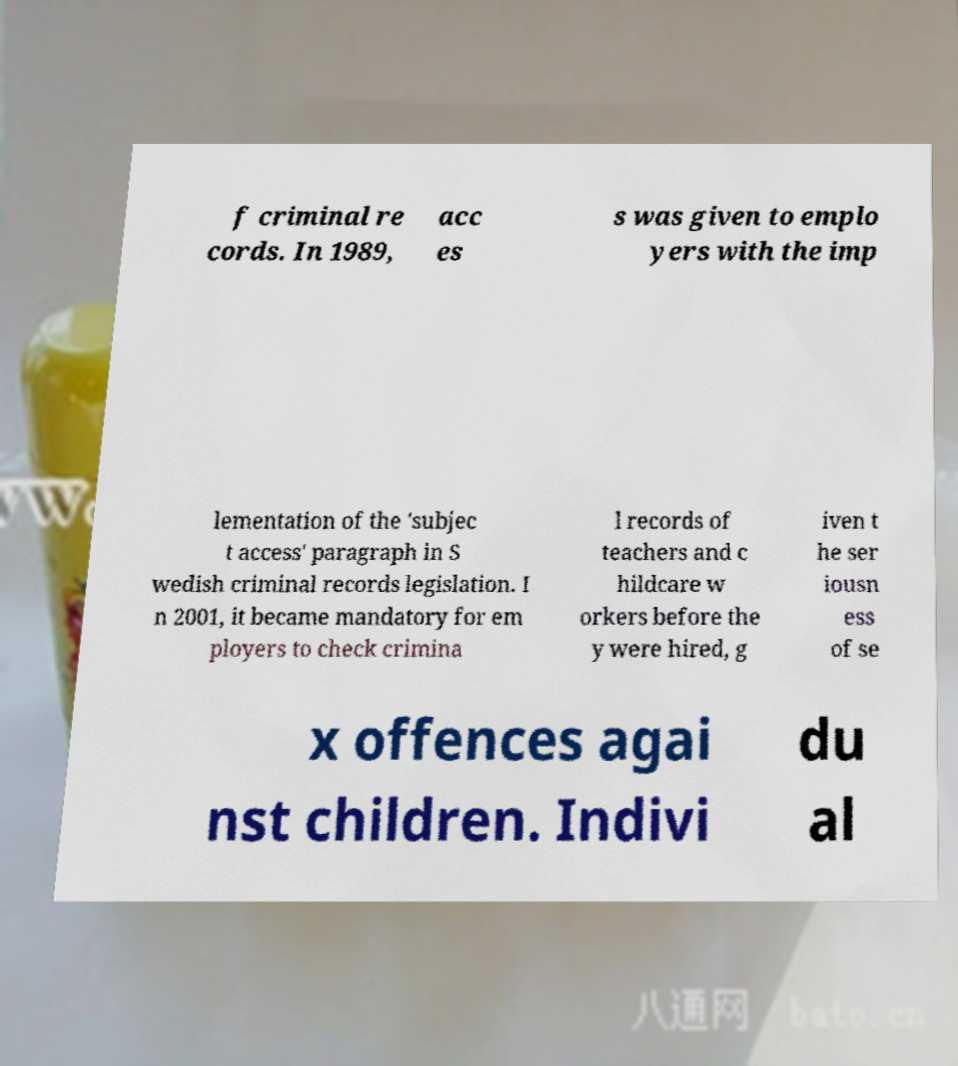Please read and relay the text visible in this image. What does it say? f criminal re cords. In 1989, acc es s was given to emplo yers with the imp lementation of the 'subjec t access' paragraph in S wedish criminal records legislation. I n 2001, it became mandatory for em ployers to check crimina l records of teachers and c hildcare w orkers before the y were hired, g iven t he ser iousn ess of se x offences agai nst children. Indivi du al 